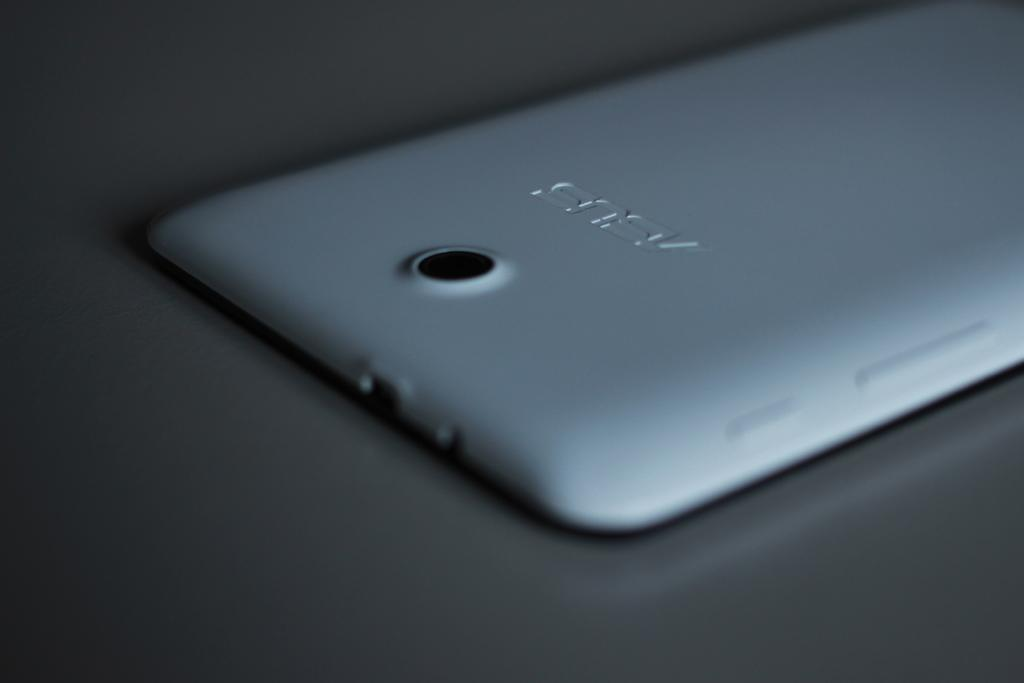<image>
Share a concise interpretation of the image provided. An ASUS phone is laying face down on a table. 